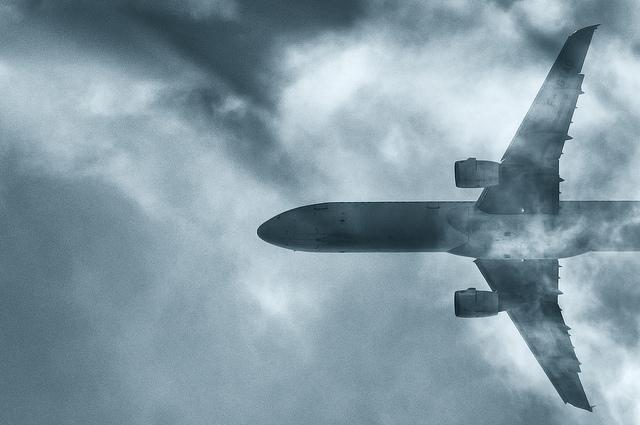What type of aircraft is this?
Be succinct. Jet. How many engines do you see?
Give a very brief answer. 2. How is the photographer positioned in relation to the plane?
Write a very short answer. Below. 